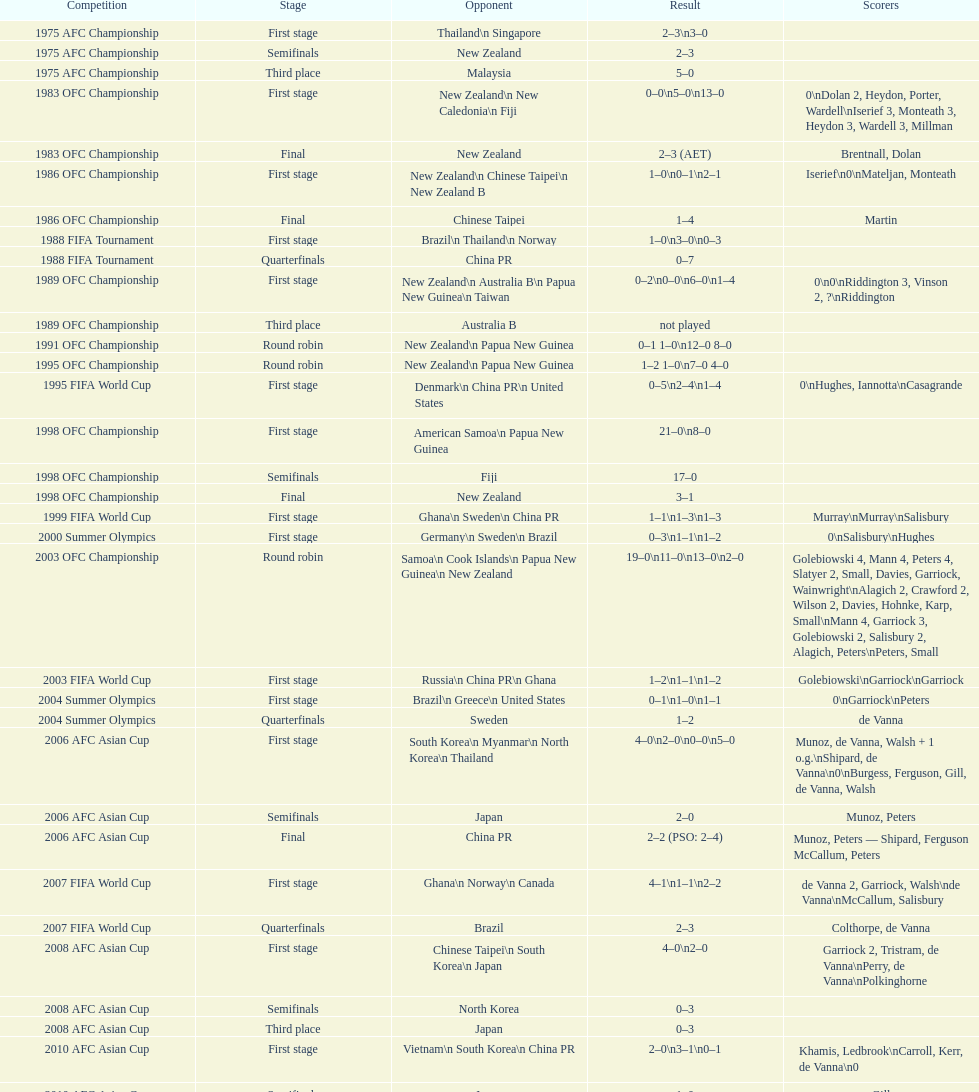How many stages were round robins? 3. 